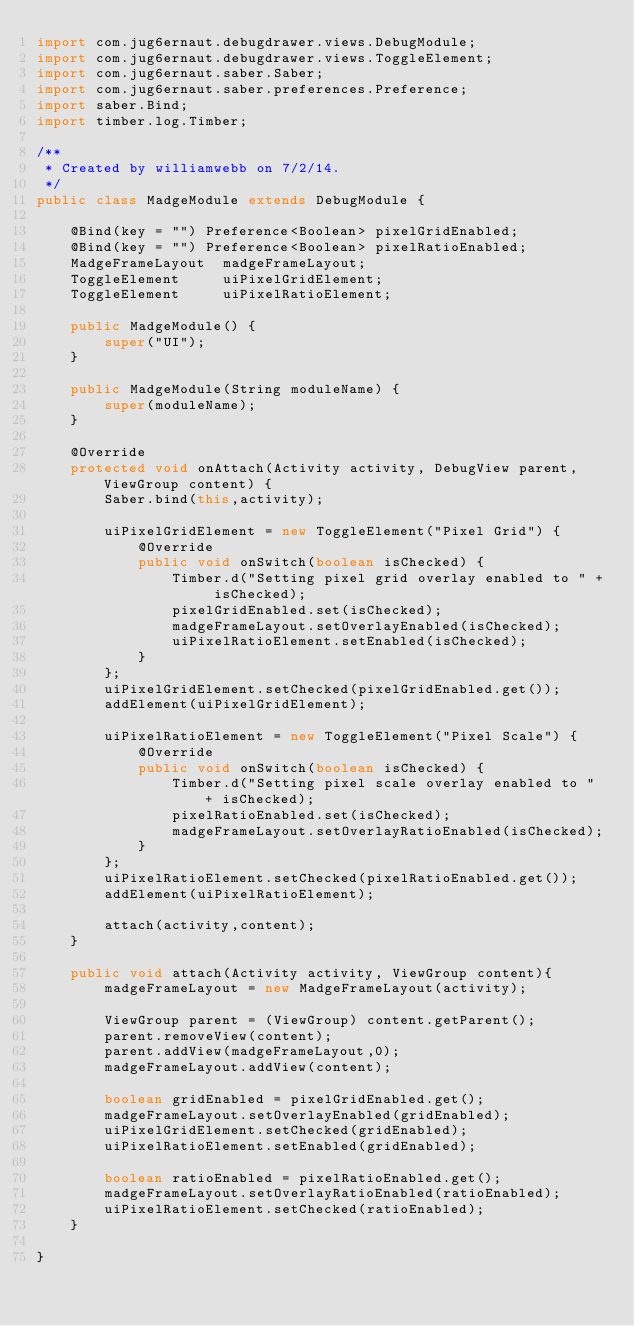<code> <loc_0><loc_0><loc_500><loc_500><_Java_>import com.jug6ernaut.debugdrawer.views.DebugModule;
import com.jug6ernaut.debugdrawer.views.ToggleElement;
import com.jug6ernaut.saber.Saber;
import com.jug6ernaut.saber.preferences.Preference;
import saber.Bind;
import timber.log.Timber;

/**
 * Created by williamwebb on 7/2/14.
 */
public class MadgeModule extends DebugModule {

    @Bind(key = "") Preference<Boolean> pixelGridEnabled;
    @Bind(key = "") Preference<Boolean> pixelRatioEnabled;
    MadgeFrameLayout  madgeFrameLayout;
    ToggleElement     uiPixelGridElement;
    ToggleElement     uiPixelRatioElement;

    public MadgeModule() {
        super("UI");
    }

    public MadgeModule(String moduleName) {
        super(moduleName);
    }

    @Override
    protected void onAttach(Activity activity, DebugView parent, ViewGroup content) {
        Saber.bind(this,activity);

        uiPixelGridElement = new ToggleElement("Pixel Grid") {
            @Override
            public void onSwitch(boolean isChecked) {
                Timber.d("Setting pixel grid overlay enabled to " + isChecked);
                pixelGridEnabled.set(isChecked);
                madgeFrameLayout.setOverlayEnabled(isChecked);
                uiPixelRatioElement.setEnabled(isChecked);
            }
        };
        uiPixelGridElement.setChecked(pixelGridEnabled.get());
        addElement(uiPixelGridElement);

        uiPixelRatioElement = new ToggleElement("Pixel Scale") {
            @Override
            public void onSwitch(boolean isChecked) {
                Timber.d("Setting pixel scale overlay enabled to " + isChecked);
                pixelRatioEnabled.set(isChecked);
                madgeFrameLayout.setOverlayRatioEnabled(isChecked);
            }
        };
        uiPixelRatioElement.setChecked(pixelRatioEnabled.get());
        addElement(uiPixelRatioElement);

        attach(activity,content);
    }

    public void attach(Activity activity, ViewGroup content){
        madgeFrameLayout = new MadgeFrameLayout(activity);

        ViewGroup parent = (ViewGroup) content.getParent();
        parent.removeView(content);
        parent.addView(madgeFrameLayout,0);
        madgeFrameLayout.addView(content);

        boolean gridEnabled = pixelGridEnabled.get();
        madgeFrameLayout.setOverlayEnabled(gridEnabled);
        uiPixelGridElement.setChecked(gridEnabled);
        uiPixelRatioElement.setEnabled(gridEnabled);

        boolean ratioEnabled = pixelRatioEnabled.get();
        madgeFrameLayout.setOverlayRatioEnabled(ratioEnabled);
        uiPixelRatioElement.setChecked(ratioEnabled);
    }

}
</code> 